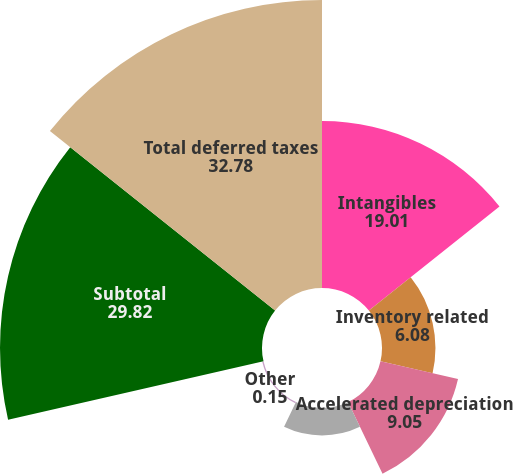Convert chart to OTSL. <chart><loc_0><loc_0><loc_500><loc_500><pie_chart><fcel>Intangibles<fcel>Inventory related<fcel>Accelerated depreciation<fcel>Pensions and other<fcel>Other<fcel>Subtotal<fcel>Total deferred taxes<nl><fcel>19.01%<fcel>6.08%<fcel>9.05%<fcel>3.12%<fcel>0.15%<fcel>29.82%<fcel>32.78%<nl></chart> 